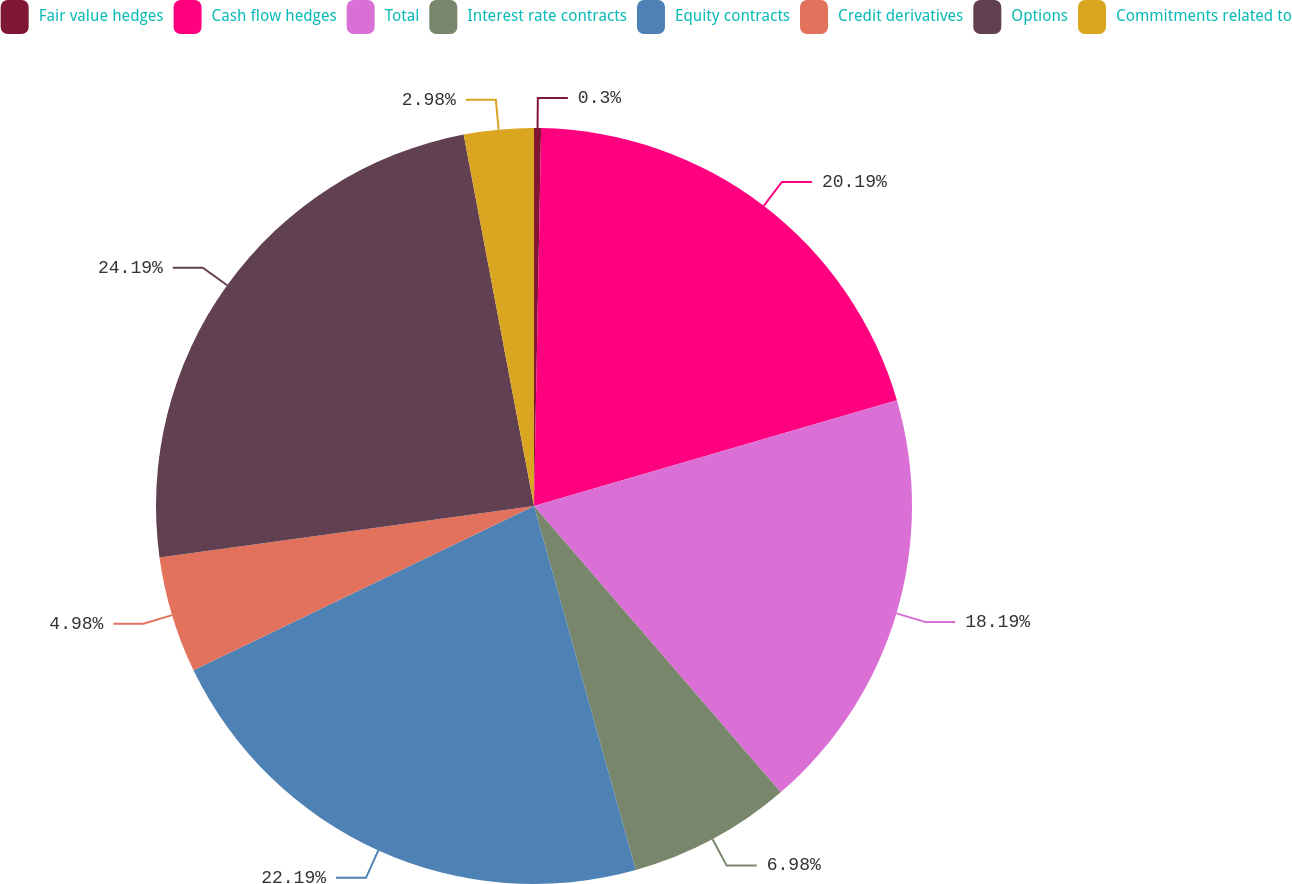Convert chart to OTSL. <chart><loc_0><loc_0><loc_500><loc_500><pie_chart><fcel>Fair value hedges<fcel>Cash flow hedges<fcel>Total<fcel>Interest rate contracts<fcel>Equity contracts<fcel>Credit derivatives<fcel>Options<fcel>Commitments related to<nl><fcel>0.3%<fcel>20.19%<fcel>18.19%<fcel>6.98%<fcel>22.19%<fcel>4.98%<fcel>24.19%<fcel>2.98%<nl></chart> 